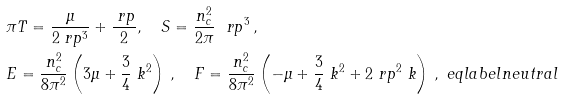<formula> <loc_0><loc_0><loc_500><loc_500>& \pi T = \frac { \mu } { 2 \ r p ^ { 3 } } + \frac { \ r p } { 2 } , \quad S = \frac { n _ { c } ^ { 2 } } { 2 \pi } \ \ r p ^ { 3 } \, , \\ & E = \frac { n _ { c } ^ { 2 } } { 8 \pi ^ { 2 } } \left ( 3 \mu + \frac { 3 } { 4 } \ k ^ { 2 } \right ) \, , \quad F = \frac { n _ { c } ^ { 2 } } { 8 \pi ^ { 2 } } \left ( - \mu + \frac { 3 } { 4 } \ k ^ { 2 } + 2 \ r p ^ { 2 } \ k \right ) \, , \ e q l a b e l { n e u t r a l }</formula> 